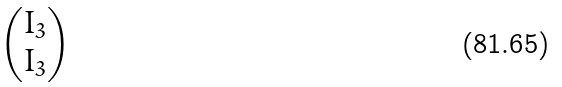Convert formula to latex. <formula><loc_0><loc_0><loc_500><loc_500>\begin{pmatrix} I _ { 3 } \\ I _ { 3 } \end{pmatrix}</formula> 